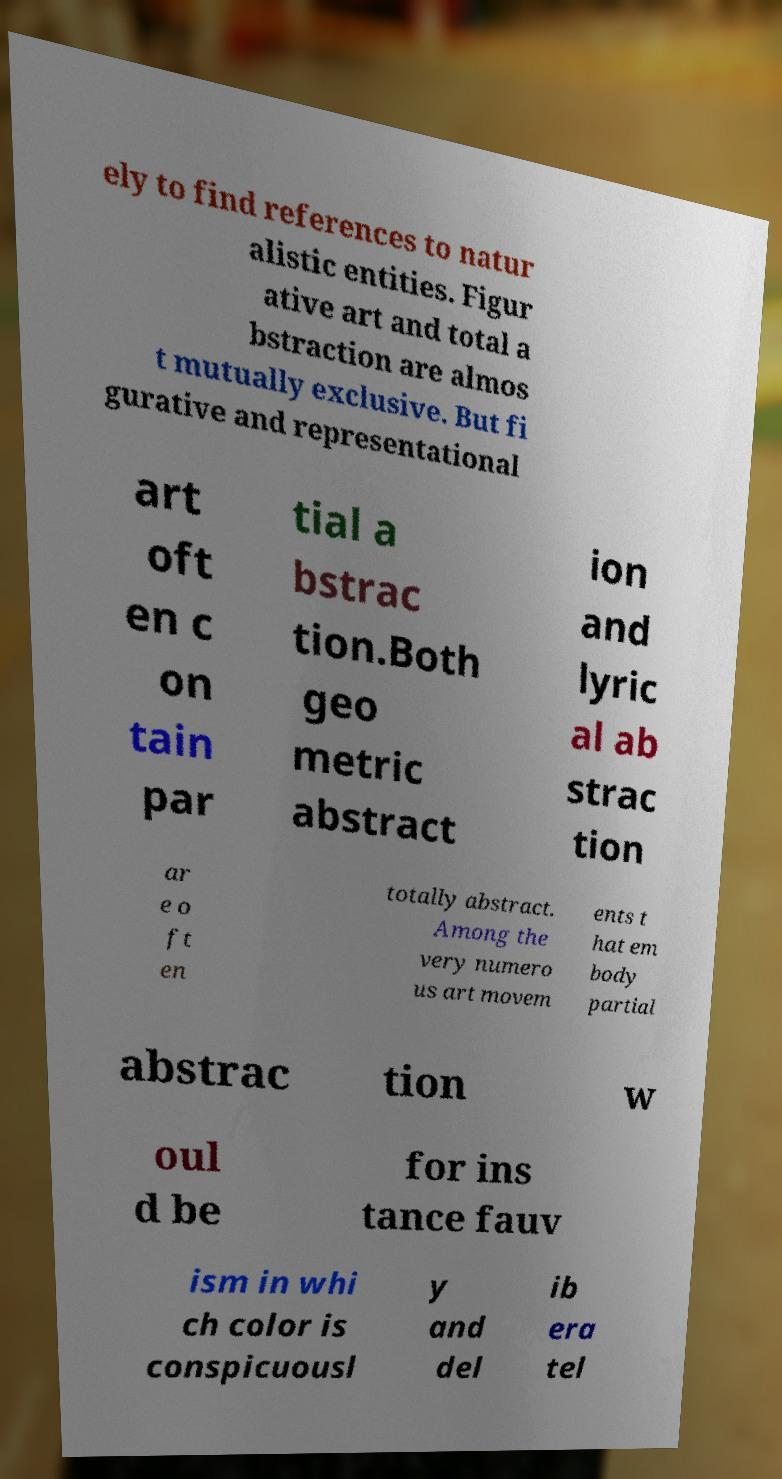Can you accurately transcribe the text from the provided image for me? ely to find references to natur alistic entities. Figur ative art and total a bstraction are almos t mutually exclusive. But fi gurative and representational art oft en c on tain par tial a bstrac tion.Both geo metric abstract ion and lyric al ab strac tion ar e o ft en totally abstract. Among the very numero us art movem ents t hat em body partial abstrac tion w oul d be for ins tance fauv ism in whi ch color is conspicuousl y and del ib era tel 